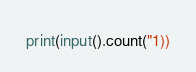Convert code to text. <code><loc_0><loc_0><loc_500><loc_500><_Python_>print(input().count("1))</code> 